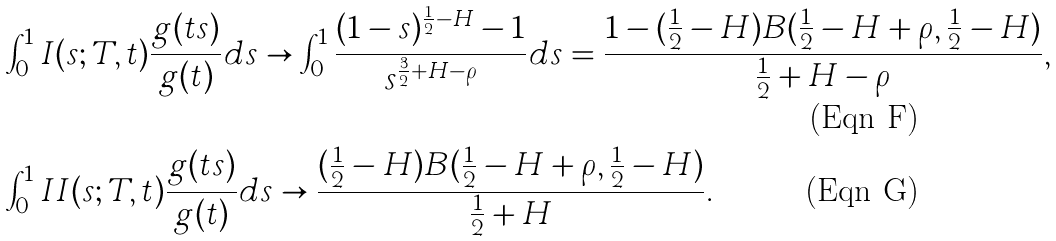Convert formula to latex. <formula><loc_0><loc_0><loc_500><loc_500>& \int _ { 0 } ^ { 1 } I ( s ; T , t ) \frac { g ( t s ) } { g ( t ) } d s \to \int _ { 0 } ^ { 1 } \frac { ( 1 - s ) ^ { \frac { 1 } { 2 } - H } - 1 } { s ^ { \frac { 3 } { 2 } + H - \rho } } d s = \frac { 1 - ( \frac { 1 } { 2 } - H ) B ( \frac { 1 } { 2 } - H + \rho , \frac { 1 } { 2 } - H ) } { \frac { 1 } { 2 } + H - \rho } , \\ & \int _ { 0 } ^ { 1 } I I ( s ; T , t ) \frac { g ( t s ) } { g ( t ) } d s \to \frac { ( \frac { 1 } { 2 } - H ) B ( \frac { 1 } { 2 } - H + \rho , \frac { 1 } { 2 } - H ) } { \frac { 1 } { 2 } + H } .</formula> 